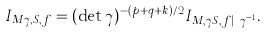Convert formula to latex. <formula><loc_0><loc_0><loc_500><loc_500>I _ { M \gamma , S , f } = ( \det \gamma ) ^ { - ( p + q + k ) / 2 } I _ { M , \gamma S , f | _ { k } \gamma ^ { - 1 } } .</formula> 